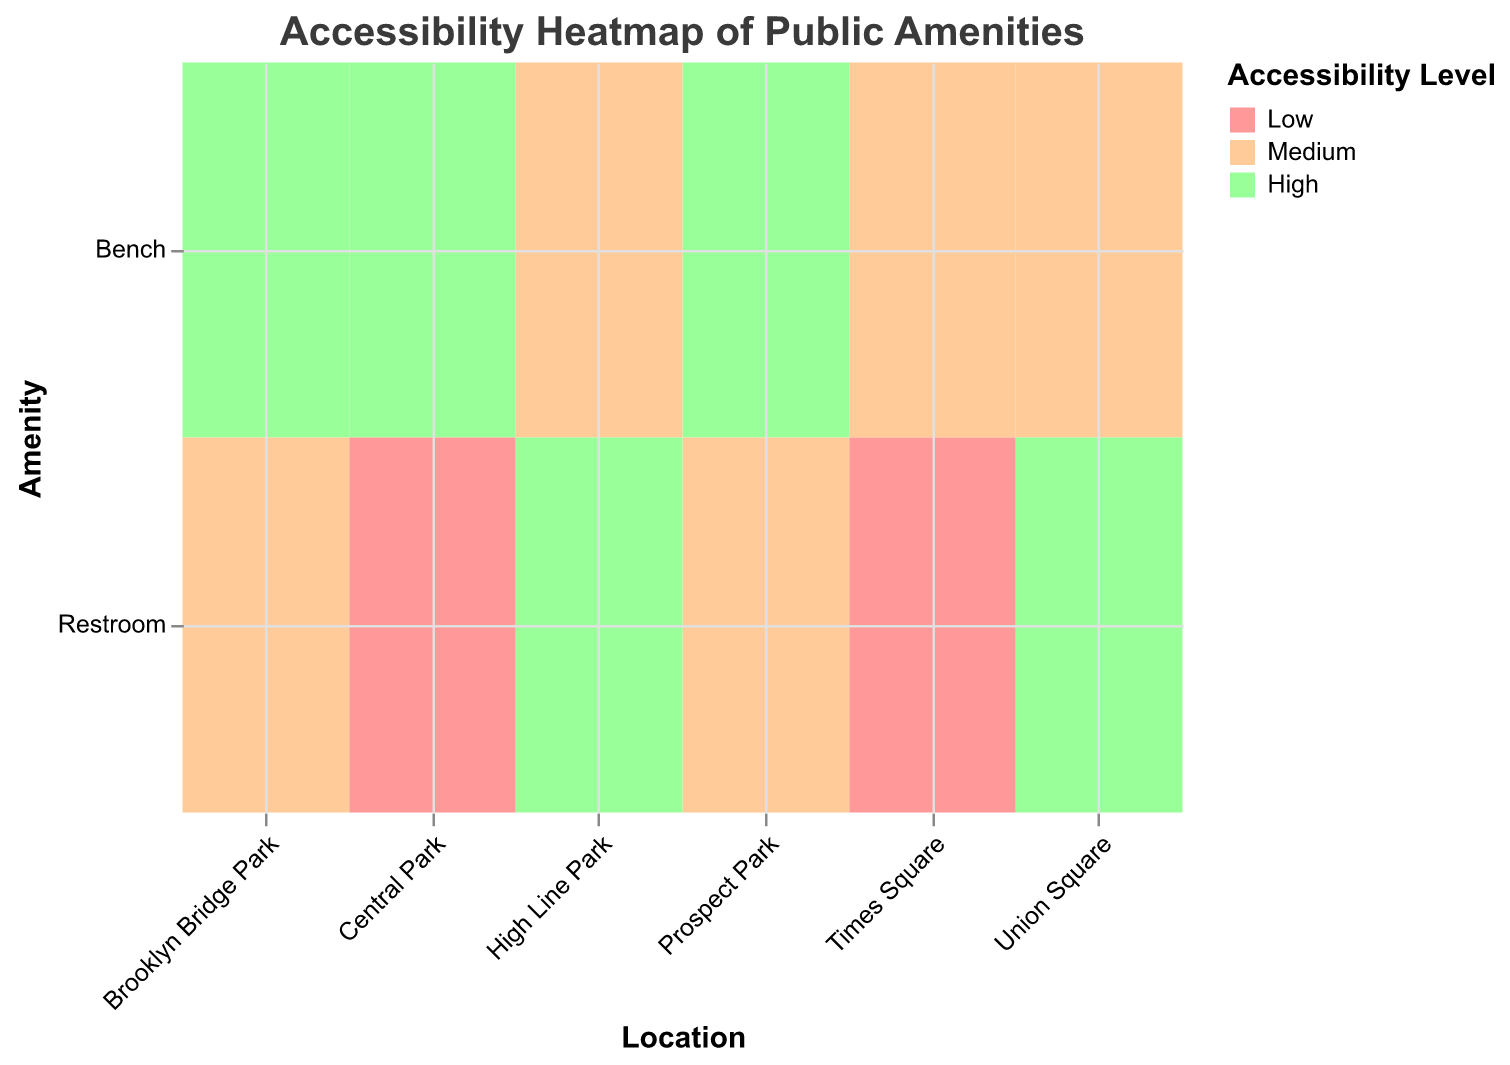What is the title of the heatmap? The title is displayed at the top center of the heatmap and reads "Accessibility Heatmap of Public Amenities."
Answer: Accessibility Heatmap of Public Amenities How many amenities have a high accessibility level? To find this, count the number of cells colored with the color representing "High" (green) in the Accessibility Level legend. There are six cells with a high accessibility level.
Answer: 6 Which location has the highest accessibility level for restrooms? To answer, look for the restroom row and find the highest accessibility level in this row. The cell for "Union Square" is colored green, indicating a high accessibility level.
Answer: Union Square How do the accessibility levels of benches compare between Central Park and Times Square? To compare, look at the "Bench" row for both locations. Central Park's bench has a high accessibility level (green), while Times Square's bench has a medium accessibility level (orange).
Answer: Central Park has higher accessibility than Times Square Which location has the most diverse accessibility levels for amenities and what are they? Check which location has the most varied colors across its amenities. Central Park has both "High" and "Low" accessibility levels, depicted in green and red.
Answer: Central Park (High, Low) Are there any amenities in the heatmap for which all given locations have the same accessibility level? Examine whether any row (either Bench or Restroom) has all cells in the same color. Both rows show different accessibility levels across locations, so this is not applicable.
Answer: No Which location has the highest overall accessibility for both benches and restrooms? Inspect each location's cells and identify where you see the most greens (high accessibility). Prospect Park has high accessibility for both benches and medium for restrooms, as does Union Square. Given that "High" trumps "Medium," Union Square with a high-restroom rating stands out.
Answer: Union Square At High Line Park, is there a difference in accessibility levels between the bench and the restroom? Consider the row of High Line Park. The Bench has a medium accessibility level (orange), whereas the Restroom has a high accessibility level (green).
Answer: Yes, the bench is medium and the restroom is high Which park has the most high accessibility amenities? Check which location has the most green cells, just focusing on the "High" accessibility level. Prospect Park has a high accessibility level for both its Bench and Restroom.
Answer: Prospect Park Is there any location where both the bench and restroom have the lowest accessibility level? Look through each location’s row for any location with two red cells. Times Square has both amenities at the lowest accessibility.
Answer: Times Square 